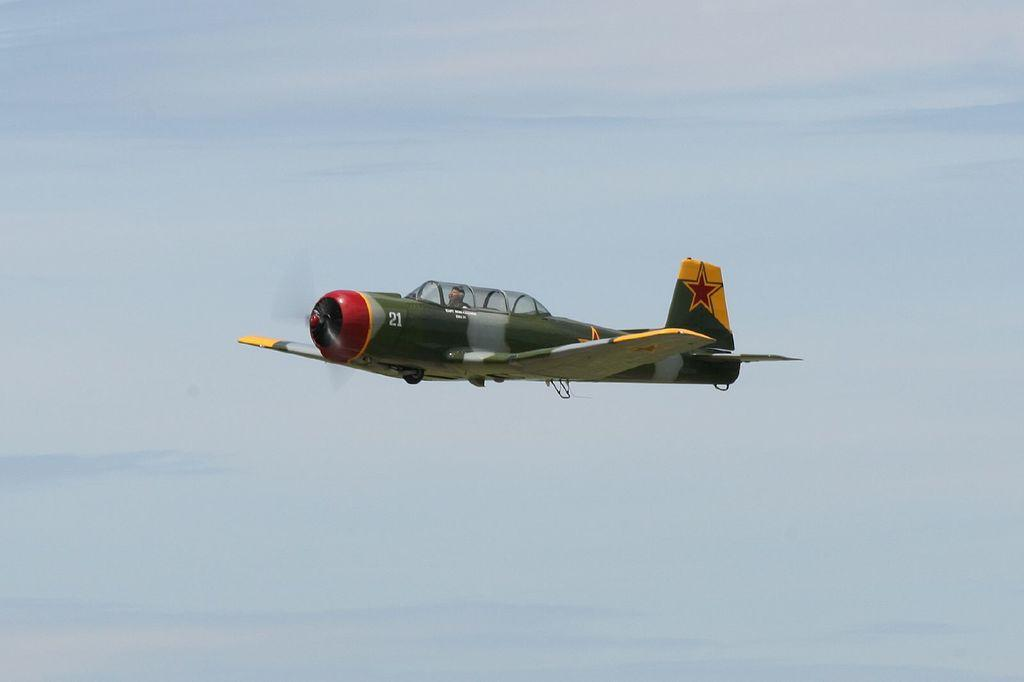What is the main subject of the image? The main subject of the image is an aircraft. What is the aircraft doing in the image? The aircraft is flying in the sky. What colors are used to paint the aircraft? The aircraft is in yellow, green, and red colors. Who is riding the aircraft? There is a man riding the aircraft. What can be seen in the background of the image? The sky is visible in the background of the image. Are there any pets visible in the image? No, there are no pets present in the image. Can you see any quicksand in the image? No, there is no quicksand visible in the image. 